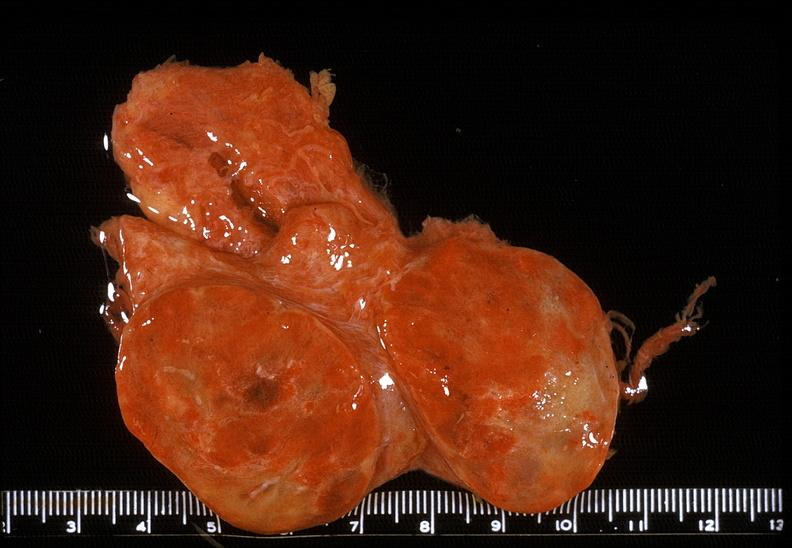does this image show thyroid, follicular adenoma?
Answer the question using a single word or phrase. Yes 